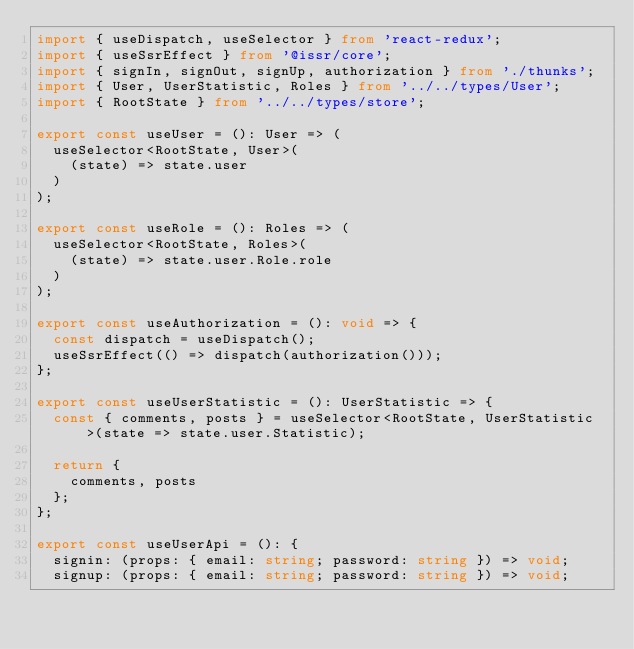Convert code to text. <code><loc_0><loc_0><loc_500><loc_500><_TypeScript_>import { useDispatch, useSelector } from 'react-redux';
import { useSsrEffect } from '@issr/core';
import { signIn, signOut, signUp, authorization } from './thunks';
import { User, UserStatistic, Roles } from '../../types/User';
import { RootState } from '../../types/store';

export const useUser = (): User => (
  useSelector<RootState, User>(
    (state) => state.user
  )
);

export const useRole = (): Roles => (
  useSelector<RootState, Roles>(
    (state) => state.user.Role.role
  )
);

export const useAuthorization = (): void => {
  const dispatch = useDispatch();
  useSsrEffect(() => dispatch(authorization()));
};

export const useUserStatistic = (): UserStatistic => {
  const { comments, posts } = useSelector<RootState, UserStatistic>(state => state.user.Statistic);

  return {
    comments, posts
  };
};

export const useUserApi = (): {
  signin: (props: { email: string; password: string }) => void;
  signup: (props: { email: string; password: string }) => void;</code> 